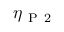<formula> <loc_0><loc_0><loc_500><loc_500>\eta _ { P 2 }</formula> 